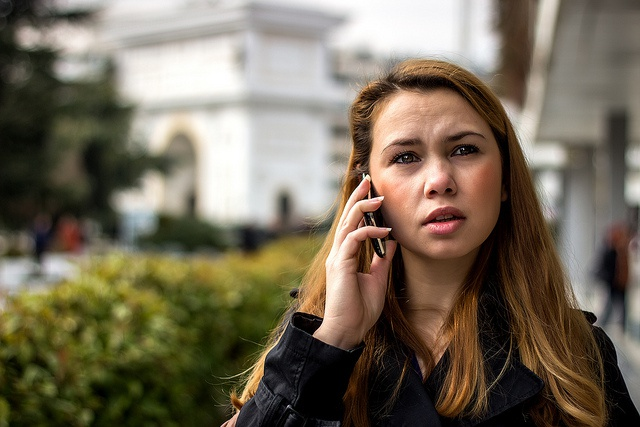Describe the objects in this image and their specific colors. I can see people in black, maroon, and brown tones and cell phone in black, gray, tan, and maroon tones in this image. 